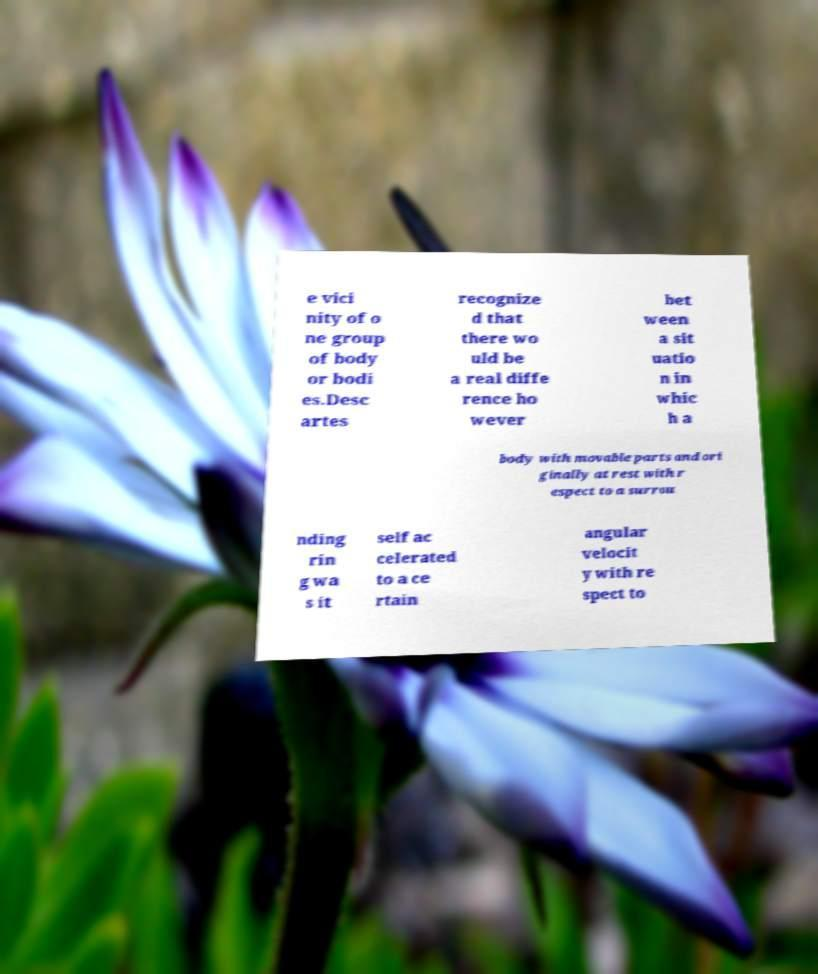Please identify and transcribe the text found in this image. e vici nity of o ne group of body or bodi es.Desc artes recognize d that there wo uld be a real diffe rence ho wever bet ween a sit uatio n in whic h a body with movable parts and ori ginally at rest with r espect to a surrou nding rin g wa s it self ac celerated to a ce rtain angular velocit y with re spect to 